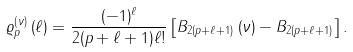<formula> <loc_0><loc_0><loc_500><loc_500>\varrho _ { p } ^ { \left ( \nu \right ) } \left ( \ell \right ) = \frac { ( - 1 ) ^ { \ell } } { 2 ( p + \ell + 1 ) \ell ! } \left [ B _ { 2 ( p + \ell + 1 ) } \left ( \nu \right ) - B _ { 2 ( p + \ell + 1 ) } \right ] .</formula> 